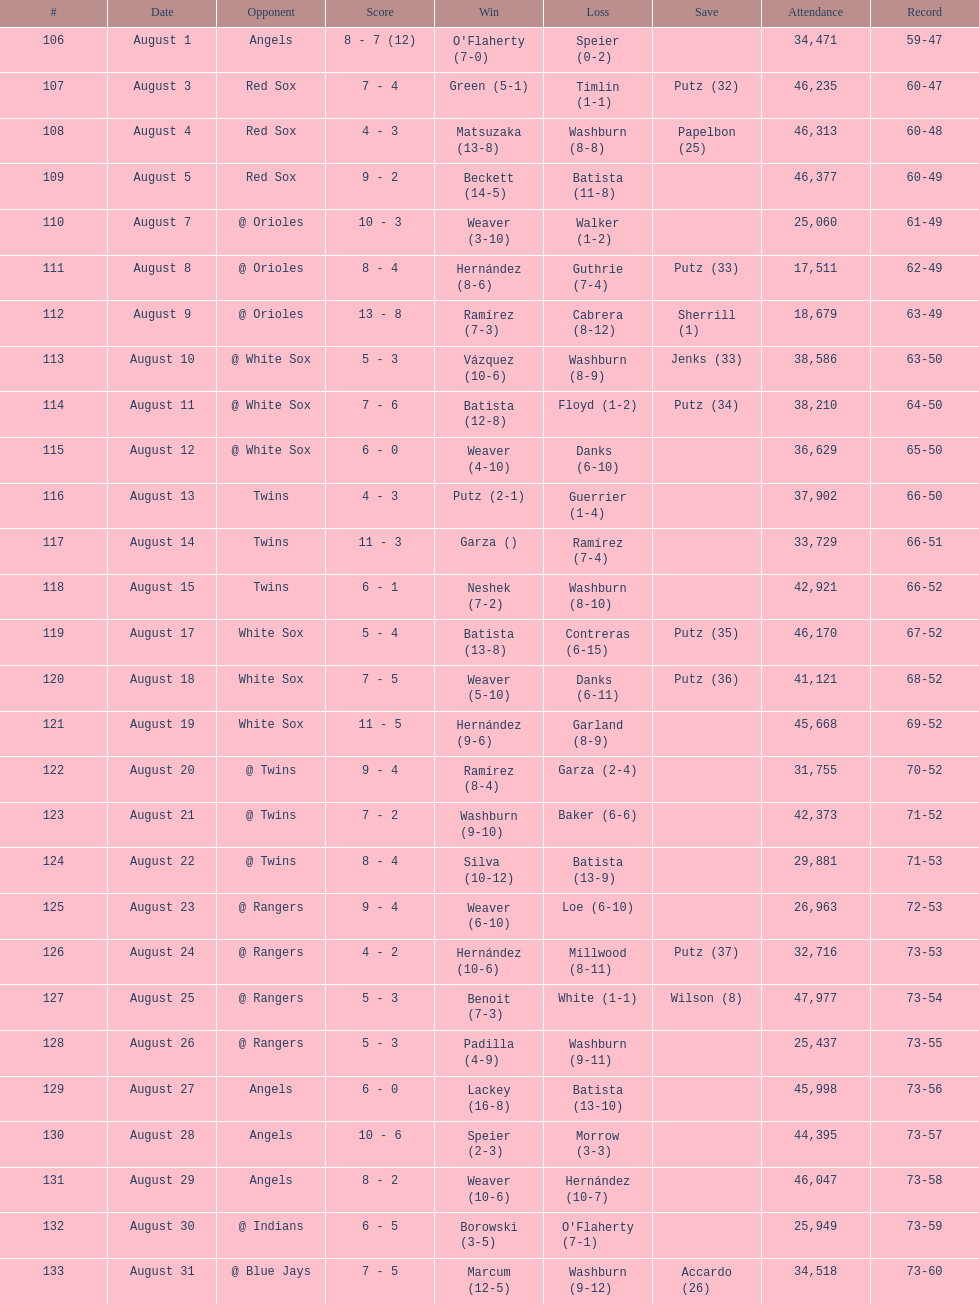What was the entire sum of games played in august 2007? 28. Help me parse the entirety of this table. {'header': ['#', 'Date', 'Opponent', 'Score', 'Win', 'Loss', 'Save', 'Attendance', 'Record'], 'rows': [['106', 'August 1', 'Angels', '8 - 7 (12)', "O'Flaherty (7-0)", 'Speier (0-2)', '', '34,471', '59-47'], ['107', 'August 3', 'Red Sox', '7 - 4', 'Green (5-1)', 'Timlin (1-1)', 'Putz (32)', '46,235', '60-47'], ['108', 'August 4', 'Red Sox', '4 - 3', 'Matsuzaka (13-8)', 'Washburn (8-8)', 'Papelbon (25)', '46,313', '60-48'], ['109', 'August 5', 'Red Sox', '9 - 2', 'Beckett (14-5)', 'Batista (11-8)', '', '46,377', '60-49'], ['110', 'August 7', '@ Orioles', '10 - 3', 'Weaver (3-10)', 'Walker (1-2)', '', '25,060', '61-49'], ['111', 'August 8', '@ Orioles', '8 - 4', 'Hernández (8-6)', 'Guthrie (7-4)', 'Putz (33)', '17,511', '62-49'], ['112', 'August 9', '@ Orioles', '13 - 8', 'Ramírez (7-3)', 'Cabrera (8-12)', 'Sherrill (1)', '18,679', '63-49'], ['113', 'August 10', '@ White Sox', '5 - 3', 'Vázquez (10-6)', 'Washburn (8-9)', 'Jenks (33)', '38,586', '63-50'], ['114', 'August 11', '@ White Sox', '7 - 6', 'Batista (12-8)', 'Floyd (1-2)', 'Putz (34)', '38,210', '64-50'], ['115', 'August 12', '@ White Sox', '6 - 0', 'Weaver (4-10)', 'Danks (6-10)', '', '36,629', '65-50'], ['116', 'August 13', 'Twins', '4 - 3', 'Putz (2-1)', 'Guerrier (1-4)', '', '37,902', '66-50'], ['117', 'August 14', 'Twins', '11 - 3', 'Garza ()', 'Ramírez (7-4)', '', '33,729', '66-51'], ['118', 'August 15', 'Twins', '6 - 1', 'Neshek (7-2)', 'Washburn (8-10)', '', '42,921', '66-52'], ['119', 'August 17', 'White Sox', '5 - 4', 'Batista (13-8)', 'Contreras (6-15)', 'Putz (35)', '46,170', '67-52'], ['120', 'August 18', 'White Sox', '7 - 5', 'Weaver (5-10)', 'Danks (6-11)', 'Putz (36)', '41,121', '68-52'], ['121', 'August 19', 'White Sox', '11 - 5', 'Hernández (9-6)', 'Garland (8-9)', '', '45,668', '69-52'], ['122', 'August 20', '@ Twins', '9 - 4', 'Ramírez (8-4)', 'Garza (2-4)', '', '31,755', '70-52'], ['123', 'August 21', '@ Twins', '7 - 2', 'Washburn (9-10)', 'Baker (6-6)', '', '42,373', '71-52'], ['124', 'August 22', '@ Twins', '8 - 4', 'Silva (10-12)', 'Batista (13-9)', '', '29,881', '71-53'], ['125', 'August 23', '@ Rangers', '9 - 4', 'Weaver (6-10)', 'Loe (6-10)', '', '26,963', '72-53'], ['126', 'August 24', '@ Rangers', '4 - 2', 'Hernández (10-6)', 'Millwood (8-11)', 'Putz (37)', '32,716', '73-53'], ['127', 'August 25', '@ Rangers', '5 - 3', 'Benoit (7-3)', 'White (1-1)', 'Wilson (8)', '47,977', '73-54'], ['128', 'August 26', '@ Rangers', '5 - 3', 'Padilla (4-9)', 'Washburn (9-11)', '', '25,437', '73-55'], ['129', 'August 27', 'Angels', '6 - 0', 'Lackey (16-8)', 'Batista (13-10)', '', '45,998', '73-56'], ['130', 'August 28', 'Angels', '10 - 6', 'Speier (2-3)', 'Morrow (3-3)', '', '44,395', '73-57'], ['131', 'August 29', 'Angels', '8 - 2', 'Weaver (10-6)', 'Hernández (10-7)', '', '46,047', '73-58'], ['132', 'August 30', '@ Indians', '6 - 5', 'Borowski (3-5)', "O'Flaherty (7-1)", '', '25,949', '73-59'], ['133', 'August 31', '@ Blue Jays', '7 - 5', 'Marcum (12-5)', 'Washburn (9-12)', 'Accardo (26)', '34,518', '73-60']]} 